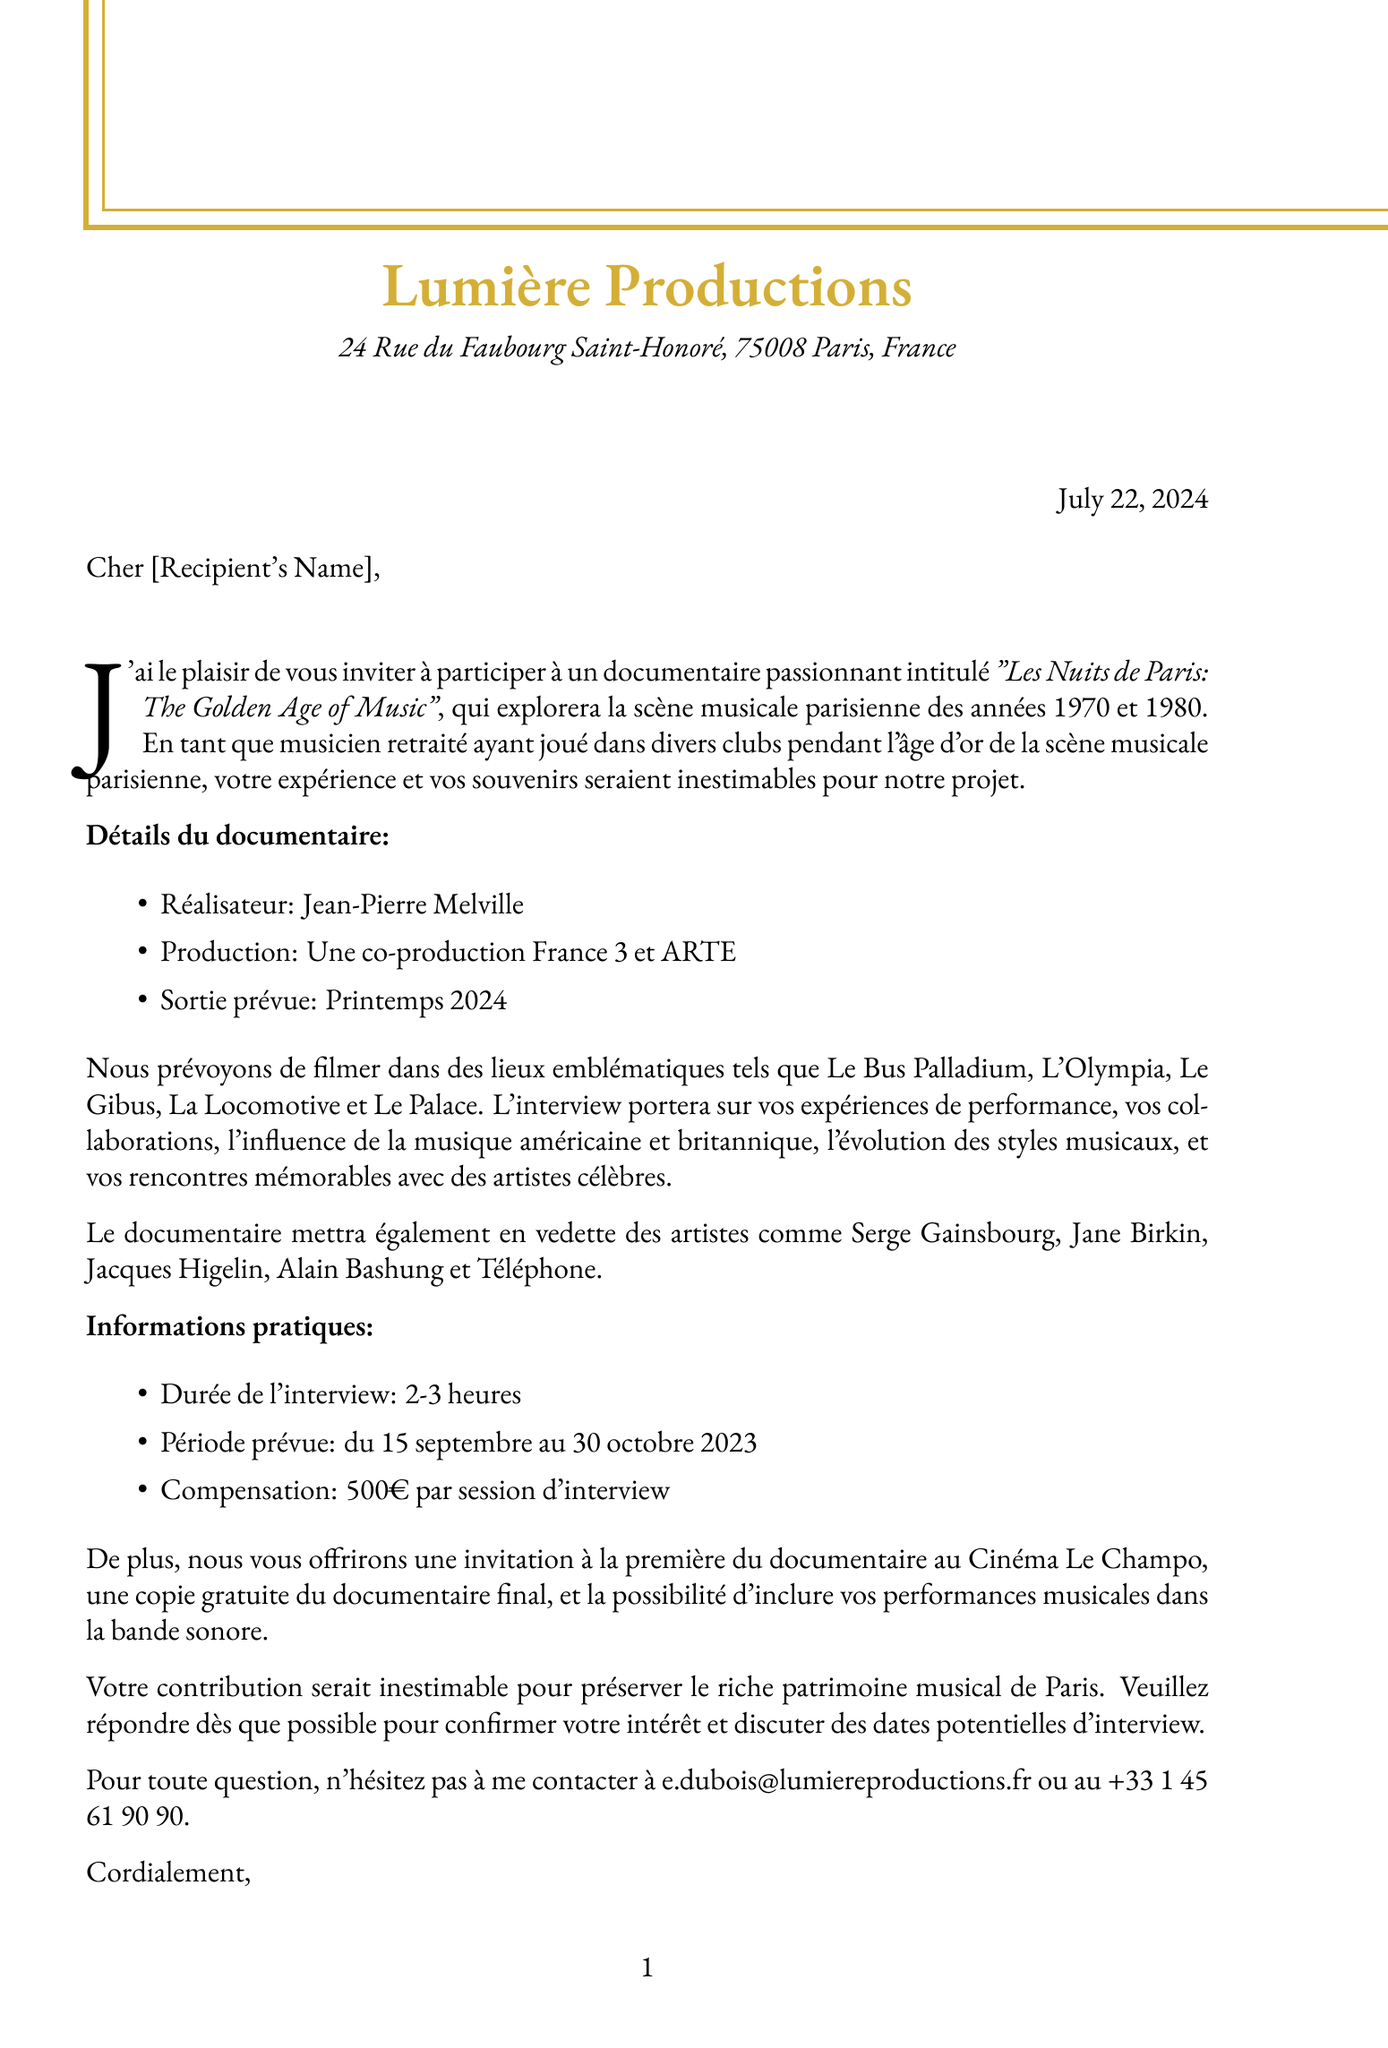What is the name of the executive producer? The document states that the executive producer of the documentary is Élise Dubois.
Answer: Élise Dubois What are the filming locations mentioned? The document lists Le Bus Palladium, L'Olympia, Le Gibus, La Locomotive, and Le Palace as filming locations.
Answer: Le Bus Palladium, L'Olympia, Le Gibus, La Locomotive, Le Palace What is the expected release date of the documentary? The document specifies that the expected release date for the documentary is Spring 2024.
Answer: Spring 2024 How long is the interview expected to last? According to the document, the interview duration is expected to be 2-3 hours.
Answer: 2-3 hours What is the compensation offered per interview session? The document indicates that the compensation offered for each interview session is €500.
Answer: €500 Who is the director of the documentary? The document names Jean-Pierre Melville as the director of the documentary.
Answer: Jean-Pierre Melville What is one of the additional incentives mentioned for participants? The document mentions an invitation to the documentary premiere at Cinéma Le Champo as an additional incentive.
Answer: Invitation to the documentary premiere at Cinéma Le Champo What type of production is this documentary? The document indicates that the documentary is a co-production between France 3 and ARTE.
Answer: A co-production France 3 and ARTE 